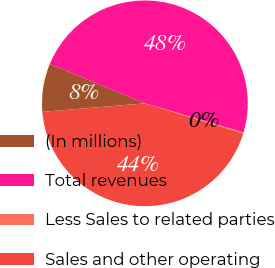<chart> <loc_0><loc_0><loc_500><loc_500><pie_chart><fcel>(In millions)<fcel>Total revenues<fcel>Less Sales to related parties<fcel>Sales and other operating<nl><fcel>7.59%<fcel>48.3%<fcel>0.21%<fcel>43.91%<nl></chart> 